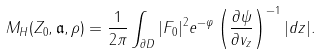<formula> <loc_0><loc_0><loc_500><loc_500>M _ { H } ( Z _ { 0 } , \mathfrak { a } , \rho ) = \frac { 1 } { 2 \pi } \int _ { \partial D } | F _ { 0 } | ^ { 2 } e ^ { - \varphi } \left ( \frac { \partial \psi } { \partial v _ { z } } \right ) ^ { - 1 } | d z | .</formula> 